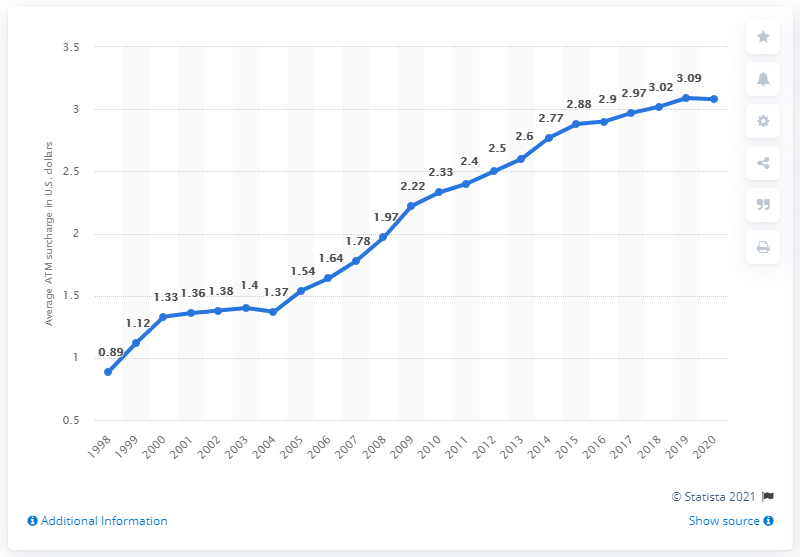Draw attention to some important aspects in this diagram. In 2020, the average ATM fee charged by banks was 3.08 USD. 